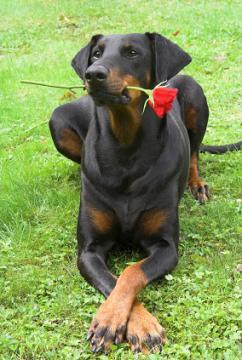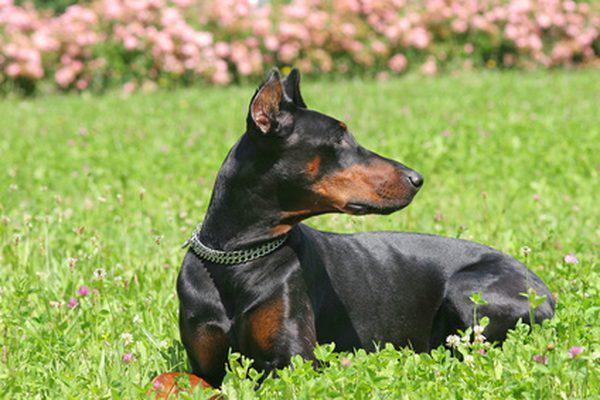The first image is the image on the left, the second image is the image on the right. Evaluate the accuracy of this statement regarding the images: "One of the dogs has uncropped ears.". Is it true? Answer yes or no. Yes. 